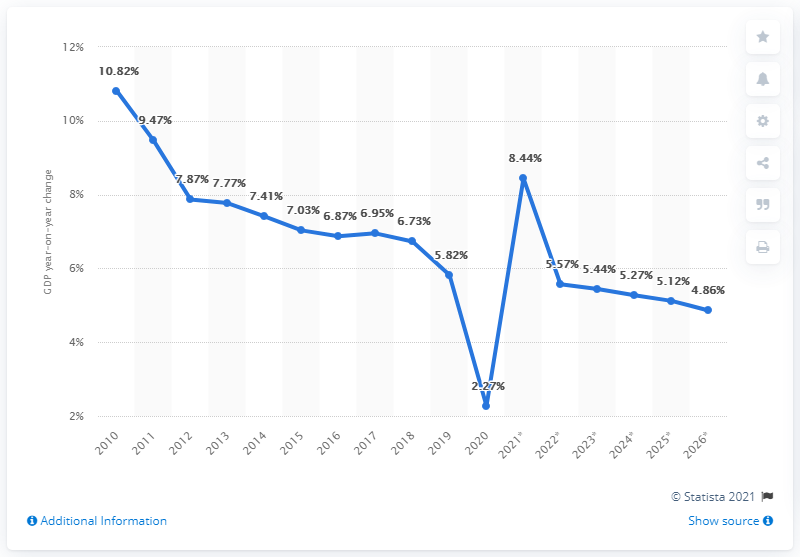List a handful of essential elements in this visual. In the year 2020, the Gross Domestic Product (GDP) underwent the most significant change. The average Gross Domestic Product (GDP) from 2010 to 2015 was 8.395. The International Monetary Fund (IMF) forecasts that the global economy will grow by 8.44% in 2021. 